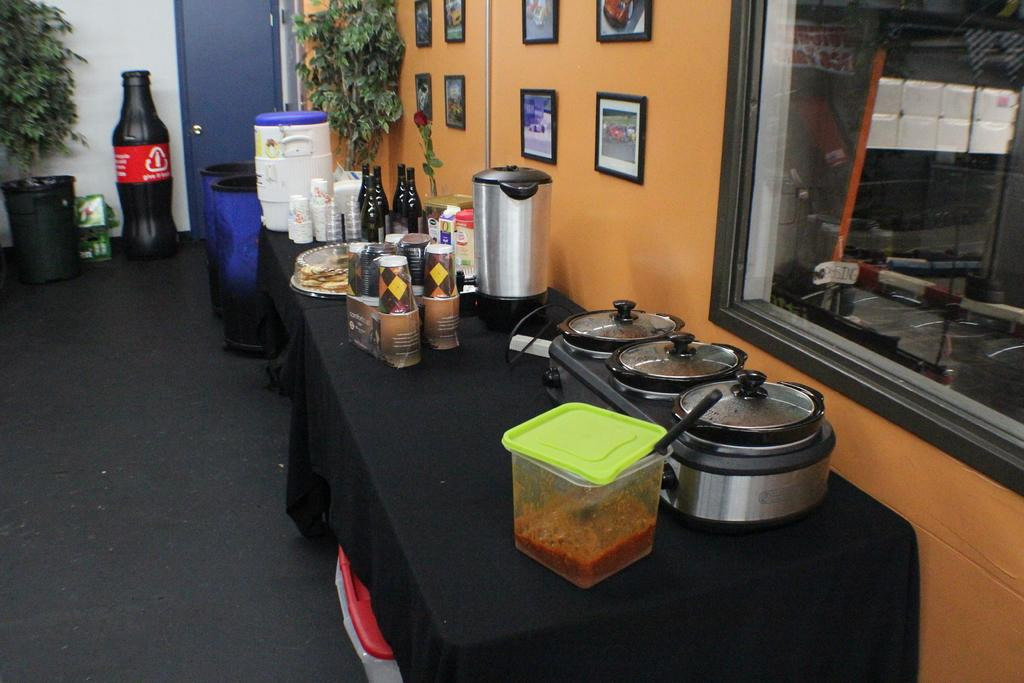<image>
Relay a brief, clear account of the picture shown. a fake coke inflatable in an office with a hazard logo on it 